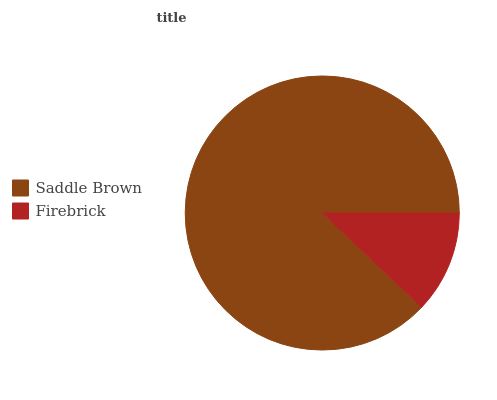Is Firebrick the minimum?
Answer yes or no. Yes. Is Saddle Brown the maximum?
Answer yes or no. Yes. Is Firebrick the maximum?
Answer yes or no. No. Is Saddle Brown greater than Firebrick?
Answer yes or no. Yes. Is Firebrick less than Saddle Brown?
Answer yes or no. Yes. Is Firebrick greater than Saddle Brown?
Answer yes or no. No. Is Saddle Brown less than Firebrick?
Answer yes or no. No. Is Saddle Brown the high median?
Answer yes or no. Yes. Is Firebrick the low median?
Answer yes or no. Yes. Is Firebrick the high median?
Answer yes or no. No. Is Saddle Brown the low median?
Answer yes or no. No. 